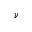<formula> <loc_0><loc_0><loc_500><loc_500>\nu</formula> 